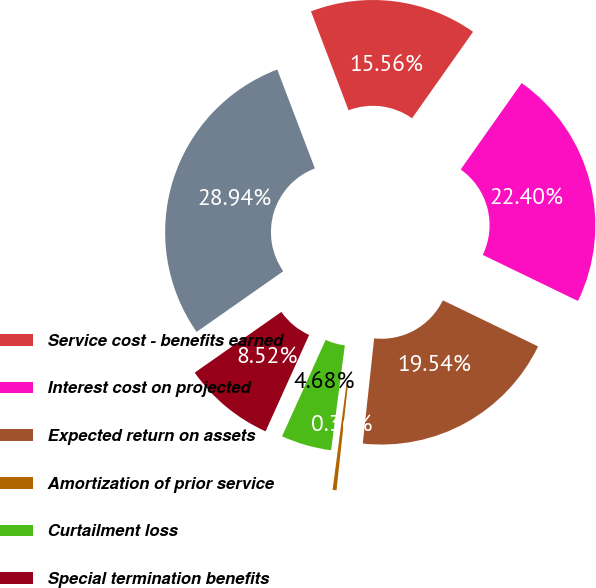<chart> <loc_0><loc_0><loc_500><loc_500><pie_chart><fcel>Service cost - benefits earned<fcel>Interest cost on projected<fcel>Expected return on assets<fcel>Amortization of prior service<fcel>Curtailment loss<fcel>Special termination benefits<fcel>Net pension cost<nl><fcel>15.56%<fcel>22.4%<fcel>19.54%<fcel>0.36%<fcel>4.68%<fcel>8.52%<fcel>28.94%<nl></chart> 